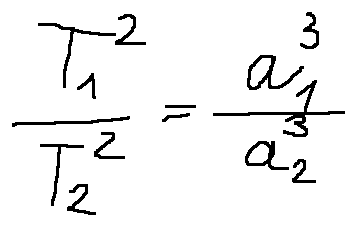Convert formula to latex. <formula><loc_0><loc_0><loc_500><loc_500>\frac { T _ { 1 } ^ { 2 } } { T _ { 2 } ^ { 2 } } = \frac { a _ { 1 } ^ { 3 } } { a _ { 2 } ^ { 3 } }</formula> 